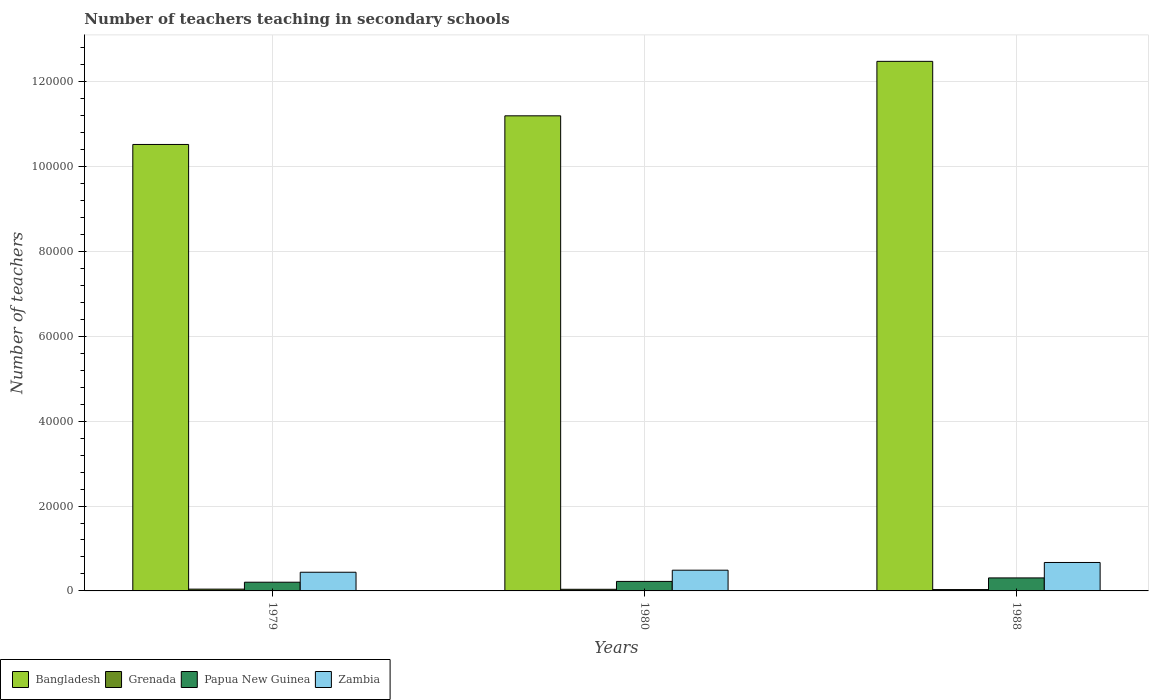How many bars are there on the 3rd tick from the left?
Your response must be concise. 4. How many bars are there on the 1st tick from the right?
Provide a succinct answer. 4. What is the label of the 1st group of bars from the left?
Provide a short and direct response. 1979. In how many cases, is the number of bars for a given year not equal to the number of legend labels?
Your answer should be compact. 0. What is the number of teachers teaching in secondary schools in Grenada in 1988?
Your response must be concise. 317. Across all years, what is the maximum number of teachers teaching in secondary schools in Papua New Guinea?
Make the answer very short. 3064. Across all years, what is the minimum number of teachers teaching in secondary schools in Zambia?
Provide a succinct answer. 4400. In which year was the number of teachers teaching in secondary schools in Papua New Guinea maximum?
Your response must be concise. 1988. In which year was the number of teachers teaching in secondary schools in Bangladesh minimum?
Make the answer very short. 1979. What is the total number of teachers teaching in secondary schools in Zambia in the graph?
Offer a terse response. 1.60e+04. What is the difference between the number of teachers teaching in secondary schools in Zambia in 1979 and that in 1980?
Give a very brief answer. -482. What is the difference between the number of teachers teaching in secondary schools in Grenada in 1988 and the number of teachers teaching in secondary schools in Papua New Guinea in 1980?
Provide a short and direct response. -1923. What is the average number of teachers teaching in secondary schools in Grenada per year?
Your response must be concise. 374.33. In the year 1979, what is the difference between the number of teachers teaching in secondary schools in Zambia and number of teachers teaching in secondary schools in Papua New Guinea?
Provide a short and direct response. 2349. In how many years, is the number of teachers teaching in secondary schools in Bangladesh greater than 100000?
Make the answer very short. 3. What is the ratio of the number of teachers teaching in secondary schools in Zambia in 1979 to that in 1988?
Provide a succinct answer. 0.66. Is the difference between the number of teachers teaching in secondary schools in Zambia in 1979 and 1980 greater than the difference between the number of teachers teaching in secondary schools in Papua New Guinea in 1979 and 1980?
Offer a very short reply. No. What is the difference between the highest and the second highest number of teachers teaching in secondary schools in Papua New Guinea?
Make the answer very short. 824. What is the difference between the highest and the lowest number of teachers teaching in secondary schools in Grenada?
Your answer should be very brief. 106. In how many years, is the number of teachers teaching in secondary schools in Grenada greater than the average number of teachers teaching in secondary schools in Grenada taken over all years?
Offer a very short reply. 2. What does the 1st bar from the left in 1979 represents?
Provide a succinct answer. Bangladesh. Is it the case that in every year, the sum of the number of teachers teaching in secondary schools in Zambia and number of teachers teaching in secondary schools in Bangladesh is greater than the number of teachers teaching in secondary schools in Papua New Guinea?
Offer a terse response. Yes. How many bars are there?
Ensure brevity in your answer.  12. Are the values on the major ticks of Y-axis written in scientific E-notation?
Provide a short and direct response. No. Where does the legend appear in the graph?
Offer a very short reply. Bottom left. How many legend labels are there?
Make the answer very short. 4. How are the legend labels stacked?
Keep it short and to the point. Horizontal. What is the title of the graph?
Keep it short and to the point. Number of teachers teaching in secondary schools. What is the label or title of the X-axis?
Give a very brief answer. Years. What is the label or title of the Y-axis?
Offer a very short reply. Number of teachers. What is the Number of teachers of Bangladesh in 1979?
Your response must be concise. 1.05e+05. What is the Number of teachers of Grenada in 1979?
Your answer should be very brief. 423. What is the Number of teachers in Papua New Guinea in 1979?
Provide a short and direct response. 2051. What is the Number of teachers in Zambia in 1979?
Give a very brief answer. 4400. What is the Number of teachers of Bangladesh in 1980?
Give a very brief answer. 1.12e+05. What is the Number of teachers of Grenada in 1980?
Provide a short and direct response. 383. What is the Number of teachers in Papua New Guinea in 1980?
Provide a short and direct response. 2240. What is the Number of teachers in Zambia in 1980?
Offer a terse response. 4882. What is the Number of teachers of Bangladesh in 1988?
Offer a terse response. 1.25e+05. What is the Number of teachers of Grenada in 1988?
Offer a terse response. 317. What is the Number of teachers in Papua New Guinea in 1988?
Provide a succinct answer. 3064. What is the Number of teachers in Zambia in 1988?
Your response must be concise. 6703. Across all years, what is the maximum Number of teachers in Bangladesh?
Give a very brief answer. 1.25e+05. Across all years, what is the maximum Number of teachers of Grenada?
Ensure brevity in your answer.  423. Across all years, what is the maximum Number of teachers of Papua New Guinea?
Offer a terse response. 3064. Across all years, what is the maximum Number of teachers in Zambia?
Your answer should be very brief. 6703. Across all years, what is the minimum Number of teachers in Bangladesh?
Your response must be concise. 1.05e+05. Across all years, what is the minimum Number of teachers of Grenada?
Give a very brief answer. 317. Across all years, what is the minimum Number of teachers in Papua New Guinea?
Ensure brevity in your answer.  2051. Across all years, what is the minimum Number of teachers of Zambia?
Your answer should be compact. 4400. What is the total Number of teachers in Bangladesh in the graph?
Ensure brevity in your answer.  3.42e+05. What is the total Number of teachers in Grenada in the graph?
Offer a terse response. 1123. What is the total Number of teachers of Papua New Guinea in the graph?
Provide a succinct answer. 7355. What is the total Number of teachers in Zambia in the graph?
Give a very brief answer. 1.60e+04. What is the difference between the Number of teachers of Bangladesh in 1979 and that in 1980?
Make the answer very short. -6745. What is the difference between the Number of teachers in Papua New Guinea in 1979 and that in 1980?
Provide a short and direct response. -189. What is the difference between the Number of teachers of Zambia in 1979 and that in 1980?
Provide a succinct answer. -482. What is the difference between the Number of teachers in Bangladesh in 1979 and that in 1988?
Ensure brevity in your answer.  -1.96e+04. What is the difference between the Number of teachers in Grenada in 1979 and that in 1988?
Offer a very short reply. 106. What is the difference between the Number of teachers in Papua New Guinea in 1979 and that in 1988?
Your answer should be compact. -1013. What is the difference between the Number of teachers of Zambia in 1979 and that in 1988?
Keep it short and to the point. -2303. What is the difference between the Number of teachers in Bangladesh in 1980 and that in 1988?
Offer a terse response. -1.28e+04. What is the difference between the Number of teachers of Grenada in 1980 and that in 1988?
Make the answer very short. 66. What is the difference between the Number of teachers of Papua New Guinea in 1980 and that in 1988?
Ensure brevity in your answer.  -824. What is the difference between the Number of teachers of Zambia in 1980 and that in 1988?
Provide a short and direct response. -1821. What is the difference between the Number of teachers in Bangladesh in 1979 and the Number of teachers in Grenada in 1980?
Provide a short and direct response. 1.05e+05. What is the difference between the Number of teachers in Bangladesh in 1979 and the Number of teachers in Papua New Guinea in 1980?
Provide a short and direct response. 1.03e+05. What is the difference between the Number of teachers in Bangladesh in 1979 and the Number of teachers in Zambia in 1980?
Provide a succinct answer. 1.00e+05. What is the difference between the Number of teachers in Grenada in 1979 and the Number of teachers in Papua New Guinea in 1980?
Offer a terse response. -1817. What is the difference between the Number of teachers in Grenada in 1979 and the Number of teachers in Zambia in 1980?
Keep it short and to the point. -4459. What is the difference between the Number of teachers of Papua New Guinea in 1979 and the Number of teachers of Zambia in 1980?
Provide a succinct answer. -2831. What is the difference between the Number of teachers of Bangladesh in 1979 and the Number of teachers of Grenada in 1988?
Offer a terse response. 1.05e+05. What is the difference between the Number of teachers in Bangladesh in 1979 and the Number of teachers in Papua New Guinea in 1988?
Your answer should be very brief. 1.02e+05. What is the difference between the Number of teachers in Bangladesh in 1979 and the Number of teachers in Zambia in 1988?
Give a very brief answer. 9.85e+04. What is the difference between the Number of teachers in Grenada in 1979 and the Number of teachers in Papua New Guinea in 1988?
Your answer should be compact. -2641. What is the difference between the Number of teachers in Grenada in 1979 and the Number of teachers in Zambia in 1988?
Provide a short and direct response. -6280. What is the difference between the Number of teachers in Papua New Guinea in 1979 and the Number of teachers in Zambia in 1988?
Give a very brief answer. -4652. What is the difference between the Number of teachers of Bangladesh in 1980 and the Number of teachers of Grenada in 1988?
Keep it short and to the point. 1.12e+05. What is the difference between the Number of teachers of Bangladesh in 1980 and the Number of teachers of Papua New Guinea in 1988?
Make the answer very short. 1.09e+05. What is the difference between the Number of teachers in Bangladesh in 1980 and the Number of teachers in Zambia in 1988?
Provide a succinct answer. 1.05e+05. What is the difference between the Number of teachers in Grenada in 1980 and the Number of teachers in Papua New Guinea in 1988?
Ensure brevity in your answer.  -2681. What is the difference between the Number of teachers in Grenada in 1980 and the Number of teachers in Zambia in 1988?
Your answer should be compact. -6320. What is the difference between the Number of teachers in Papua New Guinea in 1980 and the Number of teachers in Zambia in 1988?
Your response must be concise. -4463. What is the average Number of teachers of Bangladesh per year?
Ensure brevity in your answer.  1.14e+05. What is the average Number of teachers in Grenada per year?
Provide a succinct answer. 374.33. What is the average Number of teachers in Papua New Guinea per year?
Your answer should be compact. 2451.67. What is the average Number of teachers of Zambia per year?
Provide a succinct answer. 5328.33. In the year 1979, what is the difference between the Number of teachers of Bangladesh and Number of teachers of Grenada?
Your response must be concise. 1.05e+05. In the year 1979, what is the difference between the Number of teachers of Bangladesh and Number of teachers of Papua New Guinea?
Your answer should be very brief. 1.03e+05. In the year 1979, what is the difference between the Number of teachers in Bangladesh and Number of teachers in Zambia?
Offer a terse response. 1.01e+05. In the year 1979, what is the difference between the Number of teachers of Grenada and Number of teachers of Papua New Guinea?
Your answer should be very brief. -1628. In the year 1979, what is the difference between the Number of teachers of Grenada and Number of teachers of Zambia?
Keep it short and to the point. -3977. In the year 1979, what is the difference between the Number of teachers in Papua New Guinea and Number of teachers in Zambia?
Provide a succinct answer. -2349. In the year 1980, what is the difference between the Number of teachers in Bangladesh and Number of teachers in Grenada?
Your answer should be very brief. 1.12e+05. In the year 1980, what is the difference between the Number of teachers in Bangladesh and Number of teachers in Papua New Guinea?
Ensure brevity in your answer.  1.10e+05. In the year 1980, what is the difference between the Number of teachers of Bangladesh and Number of teachers of Zambia?
Your response must be concise. 1.07e+05. In the year 1980, what is the difference between the Number of teachers of Grenada and Number of teachers of Papua New Guinea?
Your response must be concise. -1857. In the year 1980, what is the difference between the Number of teachers of Grenada and Number of teachers of Zambia?
Make the answer very short. -4499. In the year 1980, what is the difference between the Number of teachers in Papua New Guinea and Number of teachers in Zambia?
Keep it short and to the point. -2642. In the year 1988, what is the difference between the Number of teachers in Bangladesh and Number of teachers in Grenada?
Offer a terse response. 1.24e+05. In the year 1988, what is the difference between the Number of teachers of Bangladesh and Number of teachers of Papua New Guinea?
Provide a succinct answer. 1.22e+05. In the year 1988, what is the difference between the Number of teachers in Bangladesh and Number of teachers in Zambia?
Provide a succinct answer. 1.18e+05. In the year 1988, what is the difference between the Number of teachers in Grenada and Number of teachers in Papua New Guinea?
Offer a terse response. -2747. In the year 1988, what is the difference between the Number of teachers in Grenada and Number of teachers in Zambia?
Your answer should be compact. -6386. In the year 1988, what is the difference between the Number of teachers in Papua New Guinea and Number of teachers in Zambia?
Provide a short and direct response. -3639. What is the ratio of the Number of teachers of Bangladesh in 1979 to that in 1980?
Offer a terse response. 0.94. What is the ratio of the Number of teachers in Grenada in 1979 to that in 1980?
Keep it short and to the point. 1.1. What is the ratio of the Number of teachers in Papua New Guinea in 1979 to that in 1980?
Offer a very short reply. 0.92. What is the ratio of the Number of teachers in Zambia in 1979 to that in 1980?
Provide a short and direct response. 0.9. What is the ratio of the Number of teachers of Bangladesh in 1979 to that in 1988?
Keep it short and to the point. 0.84. What is the ratio of the Number of teachers in Grenada in 1979 to that in 1988?
Ensure brevity in your answer.  1.33. What is the ratio of the Number of teachers in Papua New Guinea in 1979 to that in 1988?
Offer a terse response. 0.67. What is the ratio of the Number of teachers of Zambia in 1979 to that in 1988?
Your response must be concise. 0.66. What is the ratio of the Number of teachers in Bangladesh in 1980 to that in 1988?
Give a very brief answer. 0.9. What is the ratio of the Number of teachers of Grenada in 1980 to that in 1988?
Keep it short and to the point. 1.21. What is the ratio of the Number of teachers in Papua New Guinea in 1980 to that in 1988?
Make the answer very short. 0.73. What is the ratio of the Number of teachers of Zambia in 1980 to that in 1988?
Make the answer very short. 0.73. What is the difference between the highest and the second highest Number of teachers in Bangladesh?
Give a very brief answer. 1.28e+04. What is the difference between the highest and the second highest Number of teachers in Grenada?
Offer a terse response. 40. What is the difference between the highest and the second highest Number of teachers in Papua New Guinea?
Your answer should be compact. 824. What is the difference between the highest and the second highest Number of teachers of Zambia?
Your answer should be compact. 1821. What is the difference between the highest and the lowest Number of teachers in Bangladesh?
Give a very brief answer. 1.96e+04. What is the difference between the highest and the lowest Number of teachers in Grenada?
Offer a terse response. 106. What is the difference between the highest and the lowest Number of teachers of Papua New Guinea?
Your answer should be very brief. 1013. What is the difference between the highest and the lowest Number of teachers in Zambia?
Provide a short and direct response. 2303. 